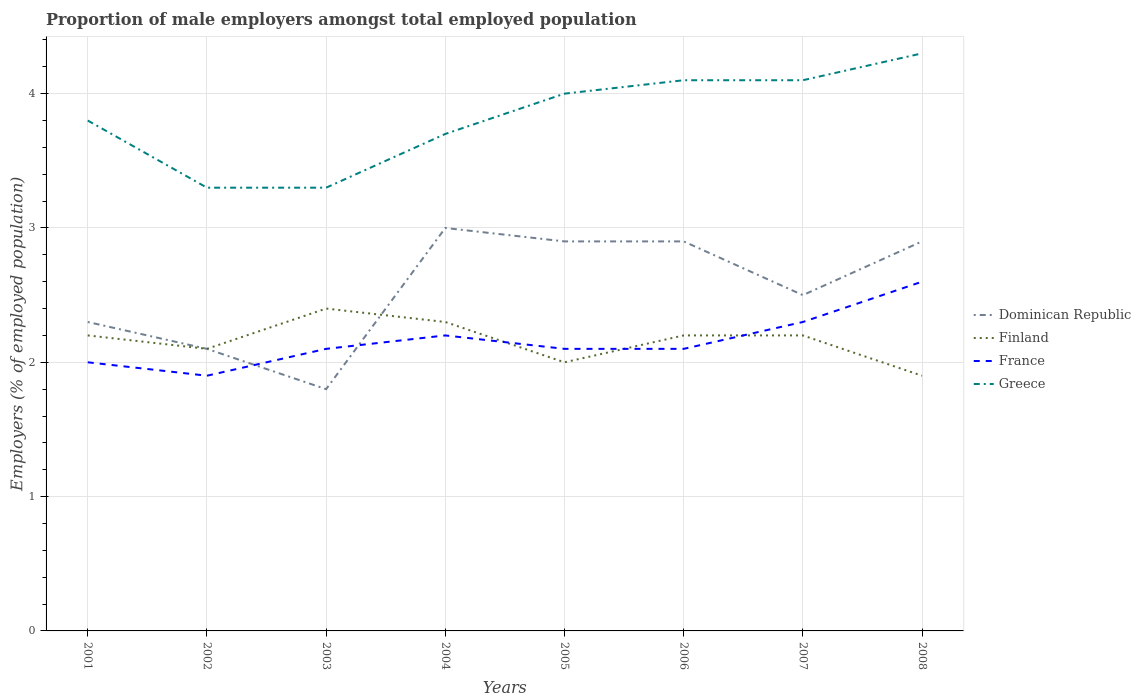How many different coloured lines are there?
Your answer should be very brief. 4. Does the line corresponding to Finland intersect with the line corresponding to France?
Give a very brief answer. Yes. Across all years, what is the maximum proportion of male employers in Finland?
Give a very brief answer. 1.9. What is the total proportion of male employers in Greece in the graph?
Make the answer very short. -0.1. What is the difference between the highest and the second highest proportion of male employers in Finland?
Ensure brevity in your answer.  0.5. What is the difference between the highest and the lowest proportion of male employers in Finland?
Make the answer very short. 5. Is the proportion of male employers in Dominican Republic strictly greater than the proportion of male employers in Finland over the years?
Give a very brief answer. No. What is the difference between two consecutive major ticks on the Y-axis?
Provide a succinct answer. 1. Does the graph contain any zero values?
Keep it short and to the point. No. How are the legend labels stacked?
Offer a very short reply. Vertical. What is the title of the graph?
Offer a terse response. Proportion of male employers amongst total employed population. Does "Portugal" appear as one of the legend labels in the graph?
Offer a terse response. No. What is the label or title of the Y-axis?
Your response must be concise. Employers (% of employed population). What is the Employers (% of employed population) in Dominican Republic in 2001?
Offer a very short reply. 2.3. What is the Employers (% of employed population) of Finland in 2001?
Provide a short and direct response. 2.2. What is the Employers (% of employed population) in Greece in 2001?
Your answer should be very brief. 3.8. What is the Employers (% of employed population) of Dominican Republic in 2002?
Offer a terse response. 2.1. What is the Employers (% of employed population) of Finland in 2002?
Your response must be concise. 2.1. What is the Employers (% of employed population) of France in 2002?
Your response must be concise. 1.9. What is the Employers (% of employed population) of Greece in 2002?
Give a very brief answer. 3.3. What is the Employers (% of employed population) in Dominican Republic in 2003?
Provide a succinct answer. 1.8. What is the Employers (% of employed population) in Finland in 2003?
Offer a very short reply. 2.4. What is the Employers (% of employed population) of France in 2003?
Ensure brevity in your answer.  2.1. What is the Employers (% of employed population) in Greece in 2003?
Your answer should be compact. 3.3. What is the Employers (% of employed population) in Dominican Republic in 2004?
Your answer should be very brief. 3. What is the Employers (% of employed population) in Finland in 2004?
Provide a short and direct response. 2.3. What is the Employers (% of employed population) of France in 2004?
Your answer should be very brief. 2.2. What is the Employers (% of employed population) of Greece in 2004?
Provide a succinct answer. 3.7. What is the Employers (% of employed population) of Dominican Republic in 2005?
Offer a terse response. 2.9. What is the Employers (% of employed population) in France in 2005?
Your answer should be compact. 2.1. What is the Employers (% of employed population) of Dominican Republic in 2006?
Provide a succinct answer. 2.9. What is the Employers (% of employed population) in Finland in 2006?
Provide a succinct answer. 2.2. What is the Employers (% of employed population) of France in 2006?
Keep it short and to the point. 2.1. What is the Employers (% of employed population) in Greece in 2006?
Your answer should be very brief. 4.1. What is the Employers (% of employed population) of Finland in 2007?
Your response must be concise. 2.2. What is the Employers (% of employed population) in France in 2007?
Offer a very short reply. 2.3. What is the Employers (% of employed population) of Greece in 2007?
Ensure brevity in your answer.  4.1. What is the Employers (% of employed population) of Dominican Republic in 2008?
Your answer should be very brief. 2.9. What is the Employers (% of employed population) of Finland in 2008?
Give a very brief answer. 1.9. What is the Employers (% of employed population) of France in 2008?
Keep it short and to the point. 2.6. What is the Employers (% of employed population) in Greece in 2008?
Your response must be concise. 4.3. Across all years, what is the maximum Employers (% of employed population) of Finland?
Keep it short and to the point. 2.4. Across all years, what is the maximum Employers (% of employed population) of France?
Your answer should be very brief. 2.6. Across all years, what is the maximum Employers (% of employed population) of Greece?
Provide a short and direct response. 4.3. Across all years, what is the minimum Employers (% of employed population) of Dominican Republic?
Your response must be concise. 1.8. Across all years, what is the minimum Employers (% of employed population) in Finland?
Keep it short and to the point. 1.9. Across all years, what is the minimum Employers (% of employed population) in France?
Your answer should be very brief. 1.9. Across all years, what is the minimum Employers (% of employed population) in Greece?
Keep it short and to the point. 3.3. What is the total Employers (% of employed population) of Dominican Republic in the graph?
Your answer should be very brief. 20.4. What is the total Employers (% of employed population) in Greece in the graph?
Your answer should be compact. 30.6. What is the difference between the Employers (% of employed population) of France in 2001 and that in 2002?
Your answer should be very brief. 0.1. What is the difference between the Employers (% of employed population) of Greece in 2001 and that in 2002?
Ensure brevity in your answer.  0.5. What is the difference between the Employers (% of employed population) in Finland in 2001 and that in 2003?
Give a very brief answer. -0.2. What is the difference between the Employers (% of employed population) of Greece in 2001 and that in 2003?
Keep it short and to the point. 0.5. What is the difference between the Employers (% of employed population) of Dominican Republic in 2001 and that in 2005?
Offer a very short reply. -0.6. What is the difference between the Employers (% of employed population) in Finland in 2001 and that in 2005?
Provide a succinct answer. 0.2. What is the difference between the Employers (% of employed population) in France in 2001 and that in 2005?
Your response must be concise. -0.1. What is the difference between the Employers (% of employed population) in Greece in 2001 and that in 2005?
Make the answer very short. -0.2. What is the difference between the Employers (% of employed population) in Dominican Republic in 2001 and that in 2006?
Give a very brief answer. -0.6. What is the difference between the Employers (% of employed population) of Finland in 2001 and that in 2006?
Your answer should be very brief. 0. What is the difference between the Employers (% of employed population) of France in 2001 and that in 2006?
Your response must be concise. -0.1. What is the difference between the Employers (% of employed population) of Finland in 2001 and that in 2007?
Your response must be concise. 0. What is the difference between the Employers (% of employed population) of Dominican Republic in 2001 and that in 2008?
Provide a short and direct response. -0.6. What is the difference between the Employers (% of employed population) in Greece in 2001 and that in 2008?
Your answer should be very brief. -0.5. What is the difference between the Employers (% of employed population) of Dominican Republic in 2002 and that in 2003?
Offer a very short reply. 0.3. What is the difference between the Employers (% of employed population) in Finland in 2002 and that in 2003?
Give a very brief answer. -0.3. What is the difference between the Employers (% of employed population) of France in 2002 and that in 2003?
Ensure brevity in your answer.  -0.2. What is the difference between the Employers (% of employed population) of Dominican Republic in 2002 and that in 2004?
Your answer should be very brief. -0.9. What is the difference between the Employers (% of employed population) of Greece in 2002 and that in 2004?
Offer a terse response. -0.4. What is the difference between the Employers (% of employed population) of Dominican Republic in 2002 and that in 2005?
Your answer should be very brief. -0.8. What is the difference between the Employers (% of employed population) of France in 2002 and that in 2005?
Ensure brevity in your answer.  -0.2. What is the difference between the Employers (% of employed population) of Greece in 2002 and that in 2005?
Offer a terse response. -0.7. What is the difference between the Employers (% of employed population) of Dominican Republic in 2002 and that in 2006?
Provide a short and direct response. -0.8. What is the difference between the Employers (% of employed population) of Finland in 2002 and that in 2006?
Your response must be concise. -0.1. What is the difference between the Employers (% of employed population) in France in 2002 and that in 2006?
Your answer should be compact. -0.2. What is the difference between the Employers (% of employed population) in Greece in 2002 and that in 2006?
Your answer should be very brief. -0.8. What is the difference between the Employers (% of employed population) of Dominican Republic in 2002 and that in 2007?
Offer a very short reply. -0.4. What is the difference between the Employers (% of employed population) of Finland in 2002 and that in 2007?
Ensure brevity in your answer.  -0.1. What is the difference between the Employers (% of employed population) in France in 2002 and that in 2007?
Your answer should be very brief. -0.4. What is the difference between the Employers (% of employed population) of Greece in 2002 and that in 2007?
Make the answer very short. -0.8. What is the difference between the Employers (% of employed population) in Dominican Republic in 2002 and that in 2008?
Make the answer very short. -0.8. What is the difference between the Employers (% of employed population) of Finland in 2002 and that in 2008?
Provide a succinct answer. 0.2. What is the difference between the Employers (% of employed population) of France in 2002 and that in 2008?
Your answer should be compact. -0.7. What is the difference between the Employers (% of employed population) in Greece in 2002 and that in 2008?
Make the answer very short. -1. What is the difference between the Employers (% of employed population) of Dominican Republic in 2003 and that in 2004?
Your answer should be compact. -1.2. What is the difference between the Employers (% of employed population) of Greece in 2003 and that in 2004?
Your answer should be compact. -0.4. What is the difference between the Employers (% of employed population) in Dominican Republic in 2003 and that in 2005?
Offer a terse response. -1.1. What is the difference between the Employers (% of employed population) of France in 2003 and that in 2005?
Offer a terse response. 0. What is the difference between the Employers (% of employed population) of Dominican Republic in 2003 and that in 2006?
Make the answer very short. -1.1. What is the difference between the Employers (% of employed population) in Finland in 2003 and that in 2006?
Your answer should be very brief. 0.2. What is the difference between the Employers (% of employed population) in France in 2003 and that in 2006?
Ensure brevity in your answer.  0. What is the difference between the Employers (% of employed population) of Dominican Republic in 2003 and that in 2007?
Provide a succinct answer. -0.7. What is the difference between the Employers (% of employed population) of France in 2003 and that in 2008?
Provide a short and direct response. -0.5. What is the difference between the Employers (% of employed population) in Dominican Republic in 2004 and that in 2005?
Make the answer very short. 0.1. What is the difference between the Employers (% of employed population) of Greece in 2004 and that in 2005?
Offer a terse response. -0.3. What is the difference between the Employers (% of employed population) in Finland in 2004 and that in 2006?
Give a very brief answer. 0.1. What is the difference between the Employers (% of employed population) of France in 2004 and that in 2006?
Offer a very short reply. 0.1. What is the difference between the Employers (% of employed population) of France in 2004 and that in 2007?
Keep it short and to the point. -0.1. What is the difference between the Employers (% of employed population) of Greece in 2004 and that in 2007?
Keep it short and to the point. -0.4. What is the difference between the Employers (% of employed population) in Dominican Republic in 2004 and that in 2008?
Offer a terse response. 0.1. What is the difference between the Employers (% of employed population) in Finland in 2004 and that in 2008?
Give a very brief answer. 0.4. What is the difference between the Employers (% of employed population) of Dominican Republic in 2005 and that in 2006?
Provide a short and direct response. 0. What is the difference between the Employers (% of employed population) of Dominican Republic in 2005 and that in 2007?
Provide a succinct answer. 0.4. What is the difference between the Employers (% of employed population) of Dominican Republic in 2005 and that in 2008?
Ensure brevity in your answer.  0. What is the difference between the Employers (% of employed population) of France in 2005 and that in 2008?
Make the answer very short. -0.5. What is the difference between the Employers (% of employed population) of Greece in 2006 and that in 2007?
Give a very brief answer. 0. What is the difference between the Employers (% of employed population) in Dominican Republic in 2006 and that in 2008?
Your response must be concise. 0. What is the difference between the Employers (% of employed population) in Finland in 2006 and that in 2008?
Your answer should be very brief. 0.3. What is the difference between the Employers (% of employed population) of Dominican Republic in 2007 and that in 2008?
Make the answer very short. -0.4. What is the difference between the Employers (% of employed population) of Finland in 2007 and that in 2008?
Provide a short and direct response. 0.3. What is the difference between the Employers (% of employed population) of France in 2007 and that in 2008?
Provide a short and direct response. -0.3. What is the difference between the Employers (% of employed population) of Dominican Republic in 2001 and the Employers (% of employed population) of France in 2002?
Make the answer very short. 0.4. What is the difference between the Employers (% of employed population) of Finland in 2001 and the Employers (% of employed population) of Greece in 2002?
Give a very brief answer. -1.1. What is the difference between the Employers (% of employed population) of France in 2001 and the Employers (% of employed population) of Greece in 2002?
Your answer should be compact. -1.3. What is the difference between the Employers (% of employed population) of Dominican Republic in 2001 and the Employers (% of employed population) of France in 2003?
Your response must be concise. 0.2. What is the difference between the Employers (% of employed population) in Finland in 2001 and the Employers (% of employed population) in France in 2003?
Give a very brief answer. 0.1. What is the difference between the Employers (% of employed population) of Dominican Republic in 2001 and the Employers (% of employed population) of Finland in 2004?
Your answer should be compact. 0. What is the difference between the Employers (% of employed population) of Dominican Republic in 2001 and the Employers (% of employed population) of Greece in 2004?
Keep it short and to the point. -1.4. What is the difference between the Employers (% of employed population) in France in 2001 and the Employers (% of employed population) in Greece in 2004?
Keep it short and to the point. -1.7. What is the difference between the Employers (% of employed population) in Dominican Republic in 2001 and the Employers (% of employed population) in Finland in 2005?
Your answer should be very brief. 0.3. What is the difference between the Employers (% of employed population) in Finland in 2001 and the Employers (% of employed population) in Greece in 2005?
Your response must be concise. -1.8. What is the difference between the Employers (% of employed population) in France in 2001 and the Employers (% of employed population) in Greece in 2005?
Your answer should be very brief. -2. What is the difference between the Employers (% of employed population) of Dominican Republic in 2001 and the Employers (% of employed population) of France in 2007?
Your answer should be very brief. 0. What is the difference between the Employers (% of employed population) in Dominican Republic in 2001 and the Employers (% of employed population) in Finland in 2008?
Make the answer very short. 0.4. What is the difference between the Employers (% of employed population) of Finland in 2001 and the Employers (% of employed population) of France in 2008?
Provide a succinct answer. -0.4. What is the difference between the Employers (% of employed population) of Finland in 2001 and the Employers (% of employed population) of Greece in 2008?
Offer a terse response. -2.1. What is the difference between the Employers (% of employed population) of France in 2001 and the Employers (% of employed population) of Greece in 2008?
Give a very brief answer. -2.3. What is the difference between the Employers (% of employed population) in Finland in 2002 and the Employers (% of employed population) in France in 2003?
Your answer should be compact. 0. What is the difference between the Employers (% of employed population) of Dominican Republic in 2002 and the Employers (% of employed population) of Finland in 2005?
Your response must be concise. 0.1. What is the difference between the Employers (% of employed population) in Dominican Republic in 2002 and the Employers (% of employed population) in Greece in 2005?
Offer a very short reply. -1.9. What is the difference between the Employers (% of employed population) of Finland in 2002 and the Employers (% of employed population) of France in 2005?
Make the answer very short. 0. What is the difference between the Employers (% of employed population) in Dominican Republic in 2002 and the Employers (% of employed population) in France in 2006?
Your answer should be very brief. 0. What is the difference between the Employers (% of employed population) of Dominican Republic in 2002 and the Employers (% of employed population) of Greece in 2006?
Your response must be concise. -2. What is the difference between the Employers (% of employed population) of Dominican Republic in 2002 and the Employers (% of employed population) of Finland in 2007?
Your answer should be very brief. -0.1. What is the difference between the Employers (% of employed population) in Dominican Republic in 2002 and the Employers (% of employed population) in Greece in 2007?
Make the answer very short. -2. What is the difference between the Employers (% of employed population) in Finland in 2002 and the Employers (% of employed population) in France in 2007?
Your answer should be compact. -0.2. What is the difference between the Employers (% of employed population) of Finland in 2002 and the Employers (% of employed population) of Greece in 2007?
Offer a terse response. -2. What is the difference between the Employers (% of employed population) of Dominican Republic in 2002 and the Employers (% of employed population) of France in 2008?
Your answer should be compact. -0.5. What is the difference between the Employers (% of employed population) in Finland in 2002 and the Employers (% of employed population) in France in 2008?
Provide a short and direct response. -0.5. What is the difference between the Employers (% of employed population) in France in 2002 and the Employers (% of employed population) in Greece in 2008?
Provide a short and direct response. -2.4. What is the difference between the Employers (% of employed population) of Dominican Republic in 2003 and the Employers (% of employed population) of Greece in 2004?
Your response must be concise. -1.9. What is the difference between the Employers (% of employed population) in Finland in 2003 and the Employers (% of employed population) in Greece in 2004?
Keep it short and to the point. -1.3. What is the difference between the Employers (% of employed population) in France in 2003 and the Employers (% of employed population) in Greece in 2004?
Your response must be concise. -1.6. What is the difference between the Employers (% of employed population) in Dominican Republic in 2003 and the Employers (% of employed population) in Finland in 2005?
Offer a very short reply. -0.2. What is the difference between the Employers (% of employed population) in Dominican Republic in 2003 and the Employers (% of employed population) in Greece in 2005?
Provide a short and direct response. -2.2. What is the difference between the Employers (% of employed population) of Finland in 2003 and the Employers (% of employed population) of Greece in 2005?
Provide a short and direct response. -1.6. What is the difference between the Employers (% of employed population) in France in 2003 and the Employers (% of employed population) in Greece in 2005?
Ensure brevity in your answer.  -1.9. What is the difference between the Employers (% of employed population) of Dominican Republic in 2003 and the Employers (% of employed population) of Finland in 2006?
Offer a very short reply. -0.4. What is the difference between the Employers (% of employed population) of Dominican Republic in 2003 and the Employers (% of employed population) of Greece in 2006?
Your answer should be compact. -2.3. What is the difference between the Employers (% of employed population) in Dominican Republic in 2003 and the Employers (% of employed population) in Finland in 2007?
Provide a short and direct response. -0.4. What is the difference between the Employers (% of employed population) in Dominican Republic in 2003 and the Employers (% of employed population) in France in 2007?
Keep it short and to the point. -0.5. What is the difference between the Employers (% of employed population) in Finland in 2003 and the Employers (% of employed population) in Greece in 2007?
Your answer should be compact. -1.7. What is the difference between the Employers (% of employed population) of Dominican Republic in 2003 and the Employers (% of employed population) of Finland in 2008?
Provide a short and direct response. -0.1. What is the difference between the Employers (% of employed population) in Dominican Republic in 2004 and the Employers (% of employed population) in France in 2005?
Make the answer very short. 0.9. What is the difference between the Employers (% of employed population) in Dominican Republic in 2004 and the Employers (% of employed population) in Greece in 2005?
Make the answer very short. -1. What is the difference between the Employers (% of employed population) of Finland in 2004 and the Employers (% of employed population) of France in 2005?
Provide a succinct answer. 0.2. What is the difference between the Employers (% of employed population) in Finland in 2004 and the Employers (% of employed population) in France in 2006?
Offer a terse response. 0.2. What is the difference between the Employers (% of employed population) in Finland in 2004 and the Employers (% of employed population) in Greece in 2006?
Keep it short and to the point. -1.8. What is the difference between the Employers (% of employed population) of France in 2004 and the Employers (% of employed population) of Greece in 2006?
Make the answer very short. -1.9. What is the difference between the Employers (% of employed population) of Dominican Republic in 2004 and the Employers (% of employed population) of Finland in 2007?
Give a very brief answer. 0.8. What is the difference between the Employers (% of employed population) of Dominican Republic in 2004 and the Employers (% of employed population) of Finland in 2008?
Your answer should be compact. 1.1. What is the difference between the Employers (% of employed population) of Dominican Republic in 2004 and the Employers (% of employed population) of France in 2008?
Give a very brief answer. 0.4. What is the difference between the Employers (% of employed population) in Finland in 2004 and the Employers (% of employed population) in France in 2008?
Your answer should be compact. -0.3. What is the difference between the Employers (% of employed population) of France in 2004 and the Employers (% of employed population) of Greece in 2008?
Your response must be concise. -2.1. What is the difference between the Employers (% of employed population) in Dominican Republic in 2005 and the Employers (% of employed population) in Finland in 2006?
Ensure brevity in your answer.  0.7. What is the difference between the Employers (% of employed population) in Finland in 2005 and the Employers (% of employed population) in Greece in 2006?
Make the answer very short. -2.1. What is the difference between the Employers (% of employed population) in Finland in 2005 and the Employers (% of employed population) in Greece in 2007?
Provide a succinct answer. -2.1. What is the difference between the Employers (% of employed population) of France in 2005 and the Employers (% of employed population) of Greece in 2007?
Ensure brevity in your answer.  -2. What is the difference between the Employers (% of employed population) of Dominican Republic in 2005 and the Employers (% of employed population) of Finland in 2008?
Your answer should be compact. 1. What is the difference between the Employers (% of employed population) of Finland in 2005 and the Employers (% of employed population) of France in 2008?
Provide a short and direct response. -0.6. What is the difference between the Employers (% of employed population) in Finland in 2005 and the Employers (% of employed population) in Greece in 2008?
Your response must be concise. -2.3. What is the difference between the Employers (% of employed population) of France in 2005 and the Employers (% of employed population) of Greece in 2008?
Make the answer very short. -2.2. What is the difference between the Employers (% of employed population) of Dominican Republic in 2006 and the Employers (% of employed population) of France in 2007?
Provide a succinct answer. 0.6. What is the difference between the Employers (% of employed population) of Finland in 2006 and the Employers (% of employed population) of France in 2007?
Provide a short and direct response. -0.1. What is the difference between the Employers (% of employed population) in Finland in 2006 and the Employers (% of employed population) in Greece in 2007?
Provide a succinct answer. -1.9. What is the difference between the Employers (% of employed population) in France in 2006 and the Employers (% of employed population) in Greece in 2007?
Your answer should be compact. -2. What is the difference between the Employers (% of employed population) of Dominican Republic in 2006 and the Employers (% of employed population) of Finland in 2008?
Provide a succinct answer. 1. What is the difference between the Employers (% of employed population) in France in 2006 and the Employers (% of employed population) in Greece in 2008?
Offer a terse response. -2.2. What is the difference between the Employers (% of employed population) of Dominican Republic in 2007 and the Employers (% of employed population) of Finland in 2008?
Offer a terse response. 0.6. What is the difference between the Employers (% of employed population) of Finland in 2007 and the Employers (% of employed population) of France in 2008?
Provide a short and direct response. -0.4. What is the difference between the Employers (% of employed population) in Finland in 2007 and the Employers (% of employed population) in Greece in 2008?
Provide a short and direct response. -2.1. What is the average Employers (% of employed population) in Dominican Republic per year?
Provide a succinct answer. 2.55. What is the average Employers (% of employed population) in Finland per year?
Provide a succinct answer. 2.16. What is the average Employers (% of employed population) of France per year?
Keep it short and to the point. 2.16. What is the average Employers (% of employed population) in Greece per year?
Give a very brief answer. 3.83. In the year 2001, what is the difference between the Employers (% of employed population) of Dominican Republic and Employers (% of employed population) of France?
Ensure brevity in your answer.  0.3. In the year 2001, what is the difference between the Employers (% of employed population) of Dominican Republic and Employers (% of employed population) of Greece?
Your response must be concise. -1.5. In the year 2001, what is the difference between the Employers (% of employed population) of Finland and Employers (% of employed population) of France?
Offer a very short reply. 0.2. In the year 2001, what is the difference between the Employers (% of employed population) in Finland and Employers (% of employed population) in Greece?
Offer a terse response. -1.6. In the year 2002, what is the difference between the Employers (% of employed population) in Dominican Republic and Employers (% of employed population) in France?
Keep it short and to the point. 0.2. In the year 2002, what is the difference between the Employers (% of employed population) in Finland and Employers (% of employed population) in Greece?
Your answer should be very brief. -1.2. In the year 2002, what is the difference between the Employers (% of employed population) in France and Employers (% of employed population) in Greece?
Make the answer very short. -1.4. In the year 2003, what is the difference between the Employers (% of employed population) of Dominican Republic and Employers (% of employed population) of Greece?
Ensure brevity in your answer.  -1.5. In the year 2003, what is the difference between the Employers (% of employed population) in Finland and Employers (% of employed population) in Greece?
Provide a short and direct response. -0.9. In the year 2004, what is the difference between the Employers (% of employed population) of Dominican Republic and Employers (% of employed population) of France?
Give a very brief answer. 0.8. In the year 2004, what is the difference between the Employers (% of employed population) of Dominican Republic and Employers (% of employed population) of Greece?
Make the answer very short. -0.7. In the year 2004, what is the difference between the Employers (% of employed population) of Finland and Employers (% of employed population) of France?
Give a very brief answer. 0.1. In the year 2004, what is the difference between the Employers (% of employed population) in Finland and Employers (% of employed population) in Greece?
Make the answer very short. -1.4. In the year 2004, what is the difference between the Employers (% of employed population) in France and Employers (% of employed population) in Greece?
Provide a short and direct response. -1.5. In the year 2005, what is the difference between the Employers (% of employed population) of Dominican Republic and Employers (% of employed population) of France?
Make the answer very short. 0.8. In the year 2005, what is the difference between the Employers (% of employed population) of Dominican Republic and Employers (% of employed population) of Greece?
Make the answer very short. -1.1. In the year 2005, what is the difference between the Employers (% of employed population) in Finland and Employers (% of employed population) in France?
Provide a succinct answer. -0.1. In the year 2005, what is the difference between the Employers (% of employed population) of Finland and Employers (% of employed population) of Greece?
Ensure brevity in your answer.  -2. In the year 2005, what is the difference between the Employers (% of employed population) in France and Employers (% of employed population) in Greece?
Offer a terse response. -1.9. In the year 2006, what is the difference between the Employers (% of employed population) in Dominican Republic and Employers (% of employed population) in Finland?
Provide a short and direct response. 0.7. In the year 2006, what is the difference between the Employers (% of employed population) of Finland and Employers (% of employed population) of France?
Your response must be concise. 0.1. In the year 2006, what is the difference between the Employers (% of employed population) in France and Employers (% of employed population) in Greece?
Offer a very short reply. -2. In the year 2007, what is the difference between the Employers (% of employed population) of Dominican Republic and Employers (% of employed population) of Greece?
Provide a short and direct response. -1.6. In the year 2007, what is the difference between the Employers (% of employed population) of Finland and Employers (% of employed population) of Greece?
Your answer should be very brief. -1.9. In the year 2007, what is the difference between the Employers (% of employed population) of France and Employers (% of employed population) of Greece?
Provide a succinct answer. -1.8. In the year 2008, what is the difference between the Employers (% of employed population) in Dominican Republic and Employers (% of employed population) in Finland?
Make the answer very short. 1. In the year 2008, what is the difference between the Employers (% of employed population) of France and Employers (% of employed population) of Greece?
Your answer should be compact. -1.7. What is the ratio of the Employers (% of employed population) of Dominican Republic in 2001 to that in 2002?
Give a very brief answer. 1.1. What is the ratio of the Employers (% of employed population) of Finland in 2001 to that in 2002?
Offer a terse response. 1.05. What is the ratio of the Employers (% of employed population) of France in 2001 to that in 2002?
Ensure brevity in your answer.  1.05. What is the ratio of the Employers (% of employed population) in Greece in 2001 to that in 2002?
Your answer should be compact. 1.15. What is the ratio of the Employers (% of employed population) in Dominican Republic in 2001 to that in 2003?
Offer a terse response. 1.28. What is the ratio of the Employers (% of employed population) in Finland in 2001 to that in 2003?
Provide a succinct answer. 0.92. What is the ratio of the Employers (% of employed population) of France in 2001 to that in 2003?
Offer a very short reply. 0.95. What is the ratio of the Employers (% of employed population) of Greece in 2001 to that in 2003?
Provide a succinct answer. 1.15. What is the ratio of the Employers (% of employed population) of Dominican Republic in 2001 to that in 2004?
Give a very brief answer. 0.77. What is the ratio of the Employers (% of employed population) of Finland in 2001 to that in 2004?
Make the answer very short. 0.96. What is the ratio of the Employers (% of employed population) in France in 2001 to that in 2004?
Offer a very short reply. 0.91. What is the ratio of the Employers (% of employed population) of Greece in 2001 to that in 2004?
Offer a very short reply. 1.03. What is the ratio of the Employers (% of employed population) in Dominican Republic in 2001 to that in 2005?
Provide a succinct answer. 0.79. What is the ratio of the Employers (% of employed population) of France in 2001 to that in 2005?
Your response must be concise. 0.95. What is the ratio of the Employers (% of employed population) in Dominican Republic in 2001 to that in 2006?
Your answer should be compact. 0.79. What is the ratio of the Employers (% of employed population) of France in 2001 to that in 2006?
Provide a succinct answer. 0.95. What is the ratio of the Employers (% of employed population) in Greece in 2001 to that in 2006?
Offer a very short reply. 0.93. What is the ratio of the Employers (% of employed population) of France in 2001 to that in 2007?
Offer a terse response. 0.87. What is the ratio of the Employers (% of employed population) of Greece in 2001 to that in 2007?
Your answer should be compact. 0.93. What is the ratio of the Employers (% of employed population) in Dominican Republic in 2001 to that in 2008?
Offer a terse response. 0.79. What is the ratio of the Employers (% of employed population) in Finland in 2001 to that in 2008?
Ensure brevity in your answer.  1.16. What is the ratio of the Employers (% of employed population) of France in 2001 to that in 2008?
Give a very brief answer. 0.77. What is the ratio of the Employers (% of employed population) in Greece in 2001 to that in 2008?
Make the answer very short. 0.88. What is the ratio of the Employers (% of employed population) of France in 2002 to that in 2003?
Ensure brevity in your answer.  0.9. What is the ratio of the Employers (% of employed population) in Greece in 2002 to that in 2003?
Ensure brevity in your answer.  1. What is the ratio of the Employers (% of employed population) in France in 2002 to that in 2004?
Provide a succinct answer. 0.86. What is the ratio of the Employers (% of employed population) of Greece in 2002 to that in 2004?
Keep it short and to the point. 0.89. What is the ratio of the Employers (% of employed population) in Dominican Republic in 2002 to that in 2005?
Provide a short and direct response. 0.72. What is the ratio of the Employers (% of employed population) in France in 2002 to that in 2005?
Provide a short and direct response. 0.9. What is the ratio of the Employers (% of employed population) of Greece in 2002 to that in 2005?
Your answer should be compact. 0.82. What is the ratio of the Employers (% of employed population) of Dominican Republic in 2002 to that in 2006?
Ensure brevity in your answer.  0.72. What is the ratio of the Employers (% of employed population) of Finland in 2002 to that in 2006?
Provide a short and direct response. 0.95. What is the ratio of the Employers (% of employed population) of France in 2002 to that in 2006?
Offer a very short reply. 0.9. What is the ratio of the Employers (% of employed population) in Greece in 2002 to that in 2006?
Your answer should be very brief. 0.8. What is the ratio of the Employers (% of employed population) of Dominican Republic in 2002 to that in 2007?
Your response must be concise. 0.84. What is the ratio of the Employers (% of employed population) of Finland in 2002 to that in 2007?
Make the answer very short. 0.95. What is the ratio of the Employers (% of employed population) of France in 2002 to that in 2007?
Keep it short and to the point. 0.83. What is the ratio of the Employers (% of employed population) in Greece in 2002 to that in 2007?
Provide a short and direct response. 0.8. What is the ratio of the Employers (% of employed population) of Dominican Republic in 2002 to that in 2008?
Give a very brief answer. 0.72. What is the ratio of the Employers (% of employed population) of Finland in 2002 to that in 2008?
Offer a terse response. 1.11. What is the ratio of the Employers (% of employed population) in France in 2002 to that in 2008?
Provide a short and direct response. 0.73. What is the ratio of the Employers (% of employed population) in Greece in 2002 to that in 2008?
Keep it short and to the point. 0.77. What is the ratio of the Employers (% of employed population) of Dominican Republic in 2003 to that in 2004?
Your response must be concise. 0.6. What is the ratio of the Employers (% of employed population) in Finland in 2003 to that in 2004?
Keep it short and to the point. 1.04. What is the ratio of the Employers (% of employed population) of France in 2003 to that in 2004?
Ensure brevity in your answer.  0.95. What is the ratio of the Employers (% of employed population) of Greece in 2003 to that in 2004?
Give a very brief answer. 0.89. What is the ratio of the Employers (% of employed population) in Dominican Republic in 2003 to that in 2005?
Provide a short and direct response. 0.62. What is the ratio of the Employers (% of employed population) of Finland in 2003 to that in 2005?
Ensure brevity in your answer.  1.2. What is the ratio of the Employers (% of employed population) in France in 2003 to that in 2005?
Your answer should be compact. 1. What is the ratio of the Employers (% of employed population) in Greece in 2003 to that in 2005?
Offer a terse response. 0.82. What is the ratio of the Employers (% of employed population) of Dominican Republic in 2003 to that in 2006?
Provide a short and direct response. 0.62. What is the ratio of the Employers (% of employed population) of Greece in 2003 to that in 2006?
Your response must be concise. 0.8. What is the ratio of the Employers (% of employed population) of Dominican Republic in 2003 to that in 2007?
Offer a very short reply. 0.72. What is the ratio of the Employers (% of employed population) in Greece in 2003 to that in 2007?
Provide a succinct answer. 0.8. What is the ratio of the Employers (% of employed population) in Dominican Republic in 2003 to that in 2008?
Offer a terse response. 0.62. What is the ratio of the Employers (% of employed population) in Finland in 2003 to that in 2008?
Your answer should be very brief. 1.26. What is the ratio of the Employers (% of employed population) of France in 2003 to that in 2008?
Offer a terse response. 0.81. What is the ratio of the Employers (% of employed population) in Greece in 2003 to that in 2008?
Give a very brief answer. 0.77. What is the ratio of the Employers (% of employed population) of Dominican Republic in 2004 to that in 2005?
Your answer should be compact. 1.03. What is the ratio of the Employers (% of employed population) in Finland in 2004 to that in 2005?
Your response must be concise. 1.15. What is the ratio of the Employers (% of employed population) in France in 2004 to that in 2005?
Your answer should be very brief. 1.05. What is the ratio of the Employers (% of employed population) of Greece in 2004 to that in 2005?
Offer a terse response. 0.93. What is the ratio of the Employers (% of employed population) of Dominican Republic in 2004 to that in 2006?
Provide a succinct answer. 1.03. What is the ratio of the Employers (% of employed population) in Finland in 2004 to that in 2006?
Ensure brevity in your answer.  1.05. What is the ratio of the Employers (% of employed population) of France in 2004 to that in 2006?
Provide a succinct answer. 1.05. What is the ratio of the Employers (% of employed population) in Greece in 2004 to that in 2006?
Offer a very short reply. 0.9. What is the ratio of the Employers (% of employed population) in Dominican Republic in 2004 to that in 2007?
Your answer should be very brief. 1.2. What is the ratio of the Employers (% of employed population) in Finland in 2004 to that in 2007?
Your answer should be compact. 1.05. What is the ratio of the Employers (% of employed population) in France in 2004 to that in 2007?
Provide a succinct answer. 0.96. What is the ratio of the Employers (% of employed population) in Greece in 2004 to that in 2007?
Give a very brief answer. 0.9. What is the ratio of the Employers (% of employed population) in Dominican Republic in 2004 to that in 2008?
Provide a succinct answer. 1.03. What is the ratio of the Employers (% of employed population) in Finland in 2004 to that in 2008?
Give a very brief answer. 1.21. What is the ratio of the Employers (% of employed population) of France in 2004 to that in 2008?
Offer a terse response. 0.85. What is the ratio of the Employers (% of employed population) of Greece in 2004 to that in 2008?
Give a very brief answer. 0.86. What is the ratio of the Employers (% of employed population) of France in 2005 to that in 2006?
Your answer should be very brief. 1. What is the ratio of the Employers (% of employed population) of Greece in 2005 to that in 2006?
Make the answer very short. 0.98. What is the ratio of the Employers (% of employed population) in Dominican Republic in 2005 to that in 2007?
Your response must be concise. 1.16. What is the ratio of the Employers (% of employed population) in Finland in 2005 to that in 2007?
Provide a succinct answer. 0.91. What is the ratio of the Employers (% of employed population) in Greece in 2005 to that in 2007?
Your response must be concise. 0.98. What is the ratio of the Employers (% of employed population) in Dominican Republic in 2005 to that in 2008?
Offer a terse response. 1. What is the ratio of the Employers (% of employed population) in Finland in 2005 to that in 2008?
Your response must be concise. 1.05. What is the ratio of the Employers (% of employed population) of France in 2005 to that in 2008?
Your answer should be compact. 0.81. What is the ratio of the Employers (% of employed population) of Greece in 2005 to that in 2008?
Provide a succinct answer. 0.93. What is the ratio of the Employers (% of employed population) of Dominican Republic in 2006 to that in 2007?
Make the answer very short. 1.16. What is the ratio of the Employers (% of employed population) of Greece in 2006 to that in 2007?
Offer a very short reply. 1. What is the ratio of the Employers (% of employed population) of Dominican Republic in 2006 to that in 2008?
Your answer should be compact. 1. What is the ratio of the Employers (% of employed population) in Finland in 2006 to that in 2008?
Give a very brief answer. 1.16. What is the ratio of the Employers (% of employed population) of France in 2006 to that in 2008?
Make the answer very short. 0.81. What is the ratio of the Employers (% of employed population) in Greece in 2006 to that in 2008?
Your response must be concise. 0.95. What is the ratio of the Employers (% of employed population) in Dominican Republic in 2007 to that in 2008?
Make the answer very short. 0.86. What is the ratio of the Employers (% of employed population) in Finland in 2007 to that in 2008?
Ensure brevity in your answer.  1.16. What is the ratio of the Employers (% of employed population) in France in 2007 to that in 2008?
Make the answer very short. 0.88. What is the ratio of the Employers (% of employed population) of Greece in 2007 to that in 2008?
Your answer should be very brief. 0.95. What is the difference between the highest and the lowest Employers (% of employed population) of Dominican Republic?
Keep it short and to the point. 1.2. 